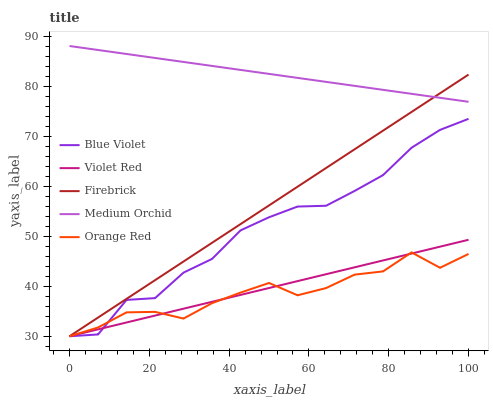Does Orange Red have the minimum area under the curve?
Answer yes or no. Yes. Does Medium Orchid have the maximum area under the curve?
Answer yes or no. Yes. Does Firebrick have the minimum area under the curve?
Answer yes or no. No. Does Firebrick have the maximum area under the curve?
Answer yes or no. No. Is Violet Red the smoothest?
Answer yes or no. Yes. Is Orange Red the roughest?
Answer yes or no. Yes. Is Medium Orchid the smoothest?
Answer yes or no. No. Is Medium Orchid the roughest?
Answer yes or no. No. Does Violet Red have the lowest value?
Answer yes or no. Yes. Does Medium Orchid have the lowest value?
Answer yes or no. No. Does Medium Orchid have the highest value?
Answer yes or no. Yes. Does Firebrick have the highest value?
Answer yes or no. No. Is Violet Red less than Medium Orchid?
Answer yes or no. Yes. Is Medium Orchid greater than Blue Violet?
Answer yes or no. Yes. Does Orange Red intersect Violet Red?
Answer yes or no. Yes. Is Orange Red less than Violet Red?
Answer yes or no. No. Is Orange Red greater than Violet Red?
Answer yes or no. No. Does Violet Red intersect Medium Orchid?
Answer yes or no. No. 